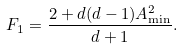<formula> <loc_0><loc_0><loc_500><loc_500>F _ { 1 } = \frac { 2 + d ( d - 1 ) A _ { \min } ^ { 2 } } { d + 1 } .</formula> 